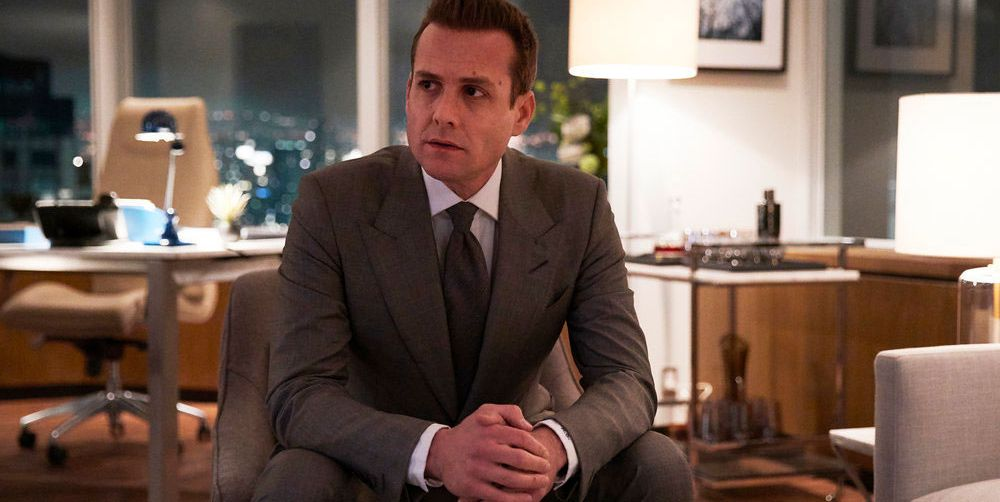Explain the visual content of the image in great detail. The image presents a man in a formal gray suit and tie, seated on the edge of a sleek, modern desk in a high-rise office. His posture is upright yet somewhat relaxed, with one hand gently clasping the other, indicating a moment of thought or decision-making. He appears focused, his gaze directed off-camera, which adds an air of contemplation or concern. The office is well-equipped and stylish, featuring a large window that reveals a panoramic view of a cityscape at night, hinting at a late working hour. The soft lighting and the city lights in the background contribute to a serene yet business-like atmosphere. 